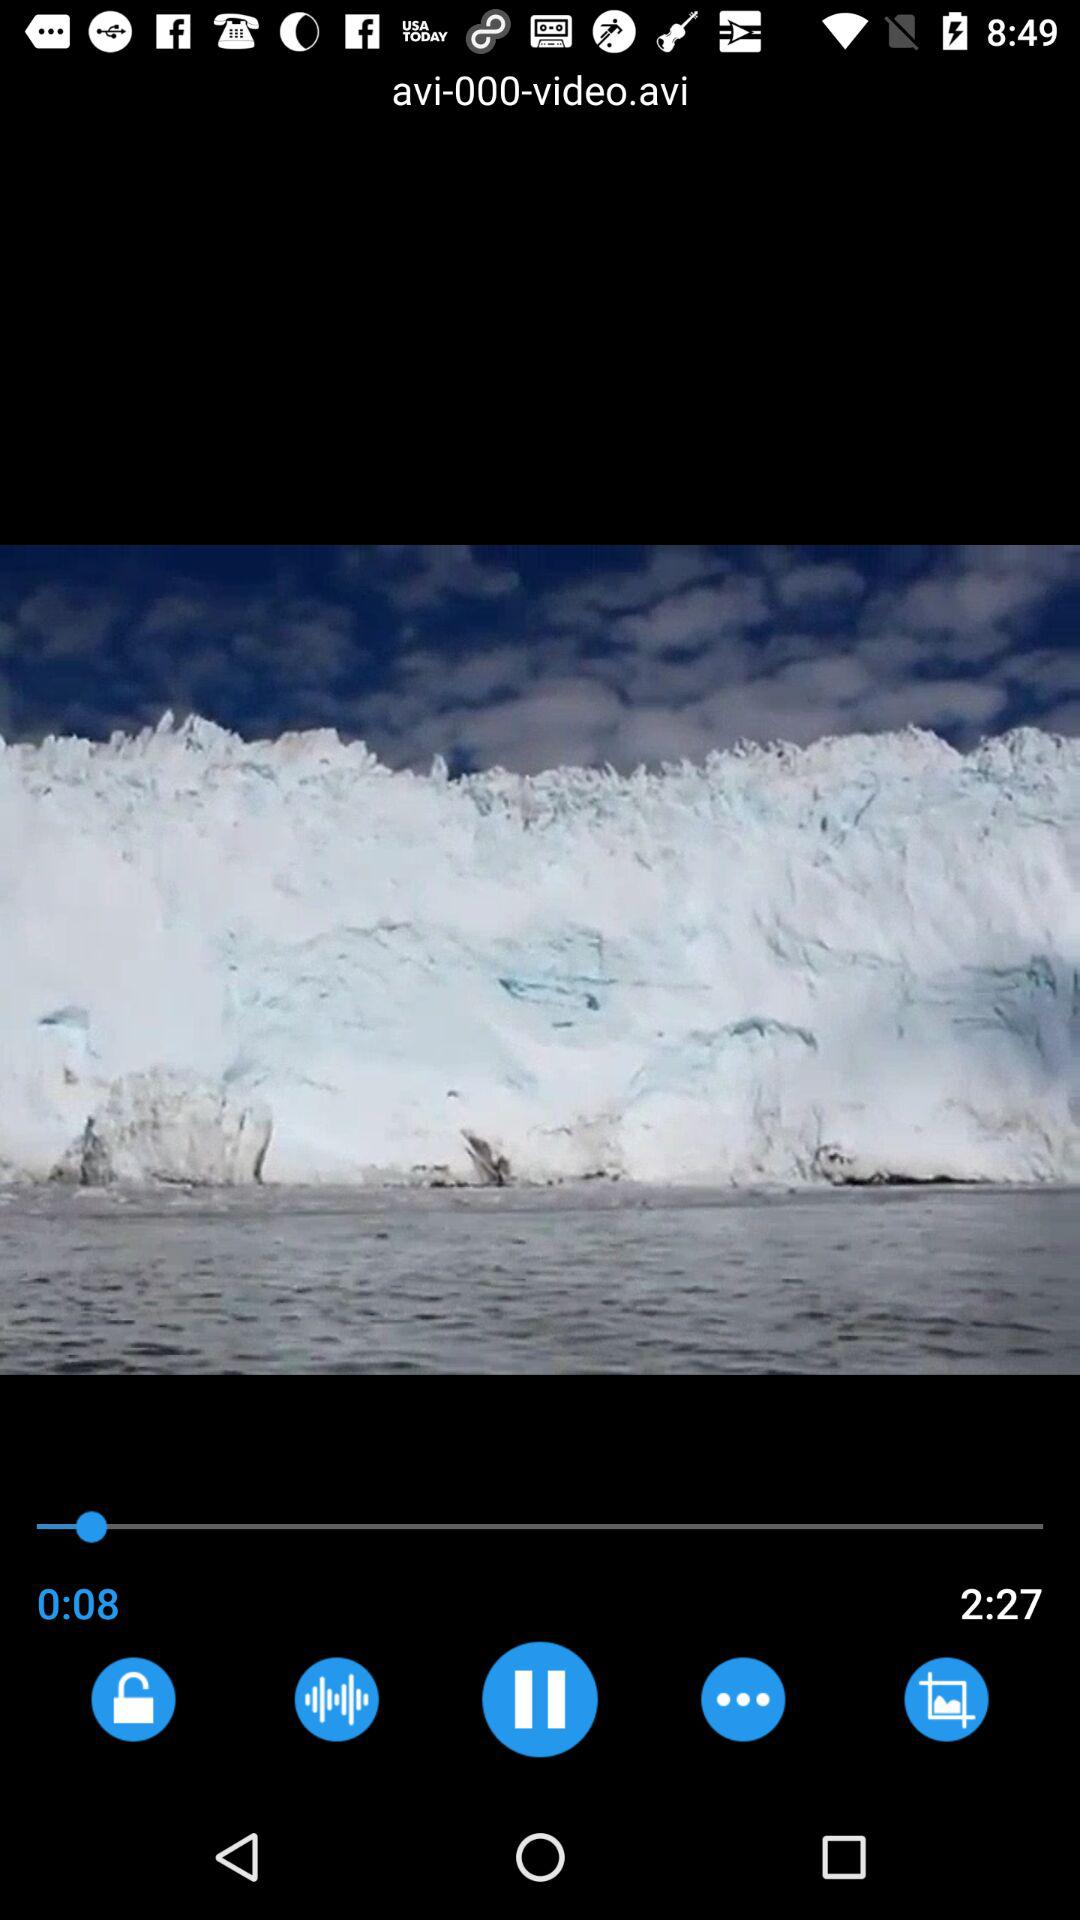How long has the video played? This video has lasted for 8 seconds. 